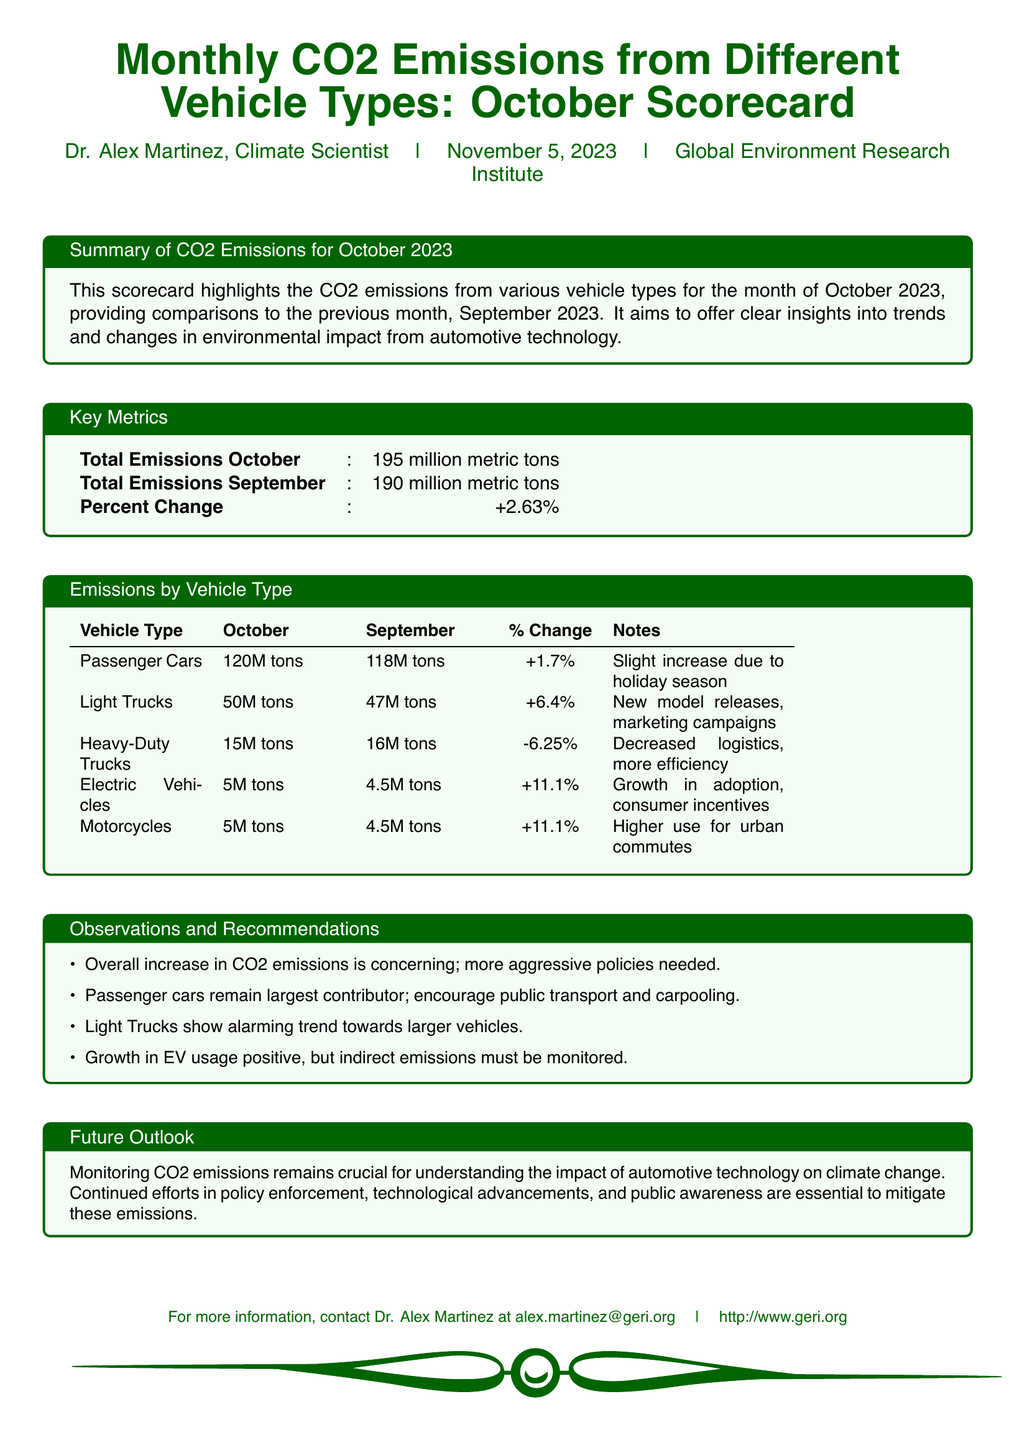What is the total CO2 emissions for October 2023? The total CO2 emissions for October 2023 are provided in the Key Metrics section, which states 195 million metric tons.
Answer: 195 million metric tons What was the percent change in CO2 emissions from September to October? The percent change is mentioned in the Key Metrics section as +2.63%.
Answer: +2.63% Which vehicle type had the highest emissions in October? The vehicle type with the highest emissions, according to the Emissions by Vehicle Type table, is Passenger Cars at 120 million tons.
Answer: Passenger Cars What is the percentage increase in Light Trucks emissions compared to September? The percentage increase for Light Trucks is indicated in the Emissions by Vehicle Type table as +6.4%.
Answer: +6.4% What notable trend is mentioned regarding Electric Vehicles? The Observations and Recommendations section notes that there is growth in adoption due to consumer incentives.
Answer: Growth in adoption, consumer incentives What recommendation is made regarding Passenger Cars? One recommendation states that encouraging public transport and carpooling is important to address emissions from Passenger Cars.
Answer: Encourage public transport and carpooling What was the total CO2 emissions for September 2023? The document provides the total emissions for September 2023 in the Key Metrics section, which is 190 million metric tons.
Answer: 190 million metric tons Which vehicle type experienced a decrease in emissions? The vehicle type that had a decrease in emissions is Heavy-Duty Trucks, as shown in the Emissions by Vehicle Type table.
Answer: Heavy-Duty Trucks 